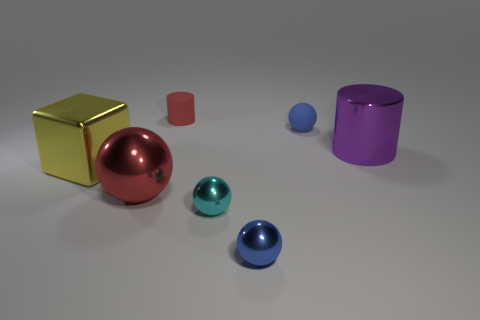There is a red thing that is the same shape as the tiny blue shiny object; what is its size?
Keep it short and to the point. Large. Is the large shiny ball the same color as the small cylinder?
Your response must be concise. Yes. What number of other things are the same material as the yellow block?
Give a very brief answer. 4. Are there an equal number of purple metal objects behind the small rubber cylinder and tiny purple shiny cylinders?
Ensure brevity in your answer.  Yes. There is a blue object that is behind the yellow cube; does it have the same size as the big sphere?
Offer a very short reply. No. What number of matte things are to the left of the small cyan object?
Make the answer very short. 1. There is a thing that is both on the left side of the cyan metallic thing and right of the red metallic thing; what material is it made of?
Make the answer very short. Rubber. What number of tiny things are yellow things or blue things?
Provide a succinct answer. 2. How big is the red matte object?
Offer a terse response. Small. What is the shape of the red metal thing?
Provide a short and direct response. Sphere. 